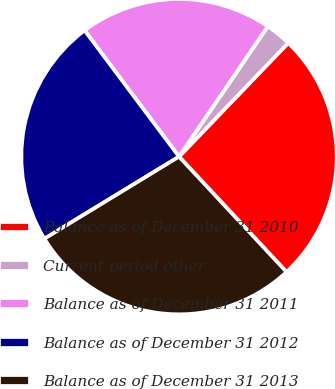<chart> <loc_0><loc_0><loc_500><loc_500><pie_chart><fcel>Balance as of December 31 2010<fcel>Current period other<fcel>Balance as of December 31 2011<fcel>Balance as of December 31 2012<fcel>Balance as of December 31 2013<nl><fcel>25.88%<fcel>2.66%<fcel>19.74%<fcel>23.49%<fcel>28.23%<nl></chart> 